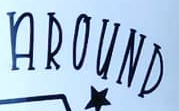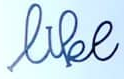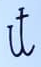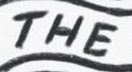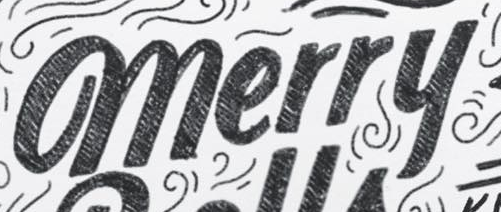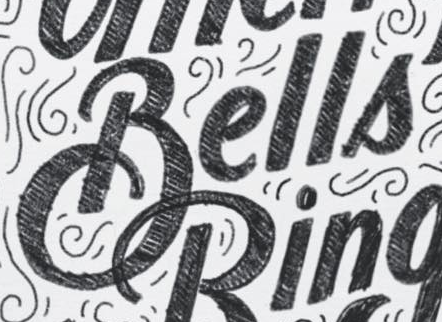Read the text from these images in sequence, separated by a semicolon. AROUND; like; it; THE; merry; Bells 